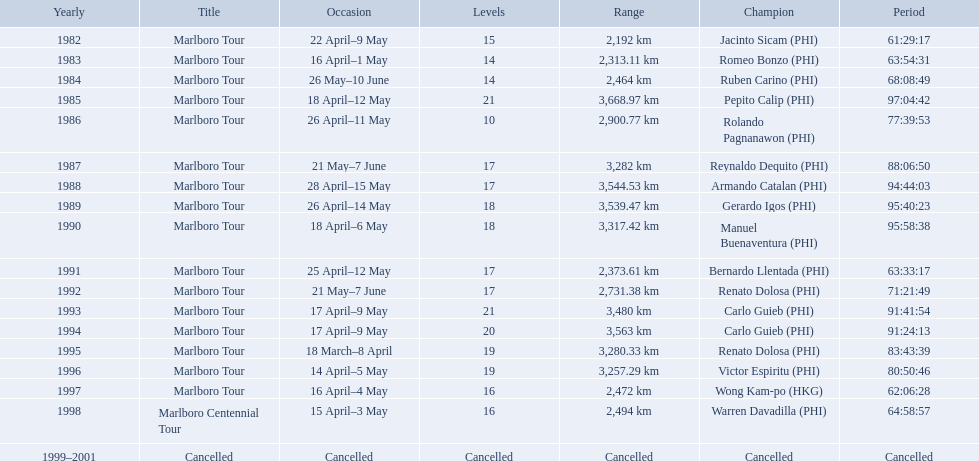What are the distances travelled on the tour? 2,192 km, 2,313.11 km, 2,464 km, 3,668.97 km, 2,900.77 km, 3,282 km, 3,544.53 km, 3,539.47 km, 3,317.42 km, 2,373.61 km, 2,731.38 km, 3,480 km, 3,563 km, 3,280.33 km, 3,257.29 km, 2,472 km, 2,494 km. Which of these are the largest? 3,668.97 km. What were the tour names during le tour de filipinas? Marlboro Tour, Marlboro Tour, Marlboro Tour, Marlboro Tour, Marlboro Tour, Marlboro Tour, Marlboro Tour, Marlboro Tour, Marlboro Tour, Marlboro Tour, Marlboro Tour, Marlboro Tour, Marlboro Tour, Marlboro Tour, Marlboro Tour, Marlboro Tour, Marlboro Centennial Tour, Cancelled. What were the recorded distances for each marlboro tour? 2,192 km, 2,313.11 km, 2,464 km, 3,668.97 km, 2,900.77 km, 3,282 km, 3,544.53 km, 3,539.47 km, 3,317.42 km, 2,373.61 km, 2,731.38 km, 3,480 km, 3,563 km, 3,280.33 km, 3,257.29 km, 2,472 km. And of those distances, which was the longest? 3,668.97 km. Who were all of the winners? Jacinto Sicam (PHI), Romeo Bonzo (PHI), Ruben Carino (PHI), Pepito Calip (PHI), Rolando Pagnanawon (PHI), Reynaldo Dequito (PHI), Armando Catalan (PHI), Gerardo Igos (PHI), Manuel Buenaventura (PHI), Bernardo Llentada (PHI), Renato Dolosa (PHI), Carlo Guieb (PHI), Carlo Guieb (PHI), Renato Dolosa (PHI), Victor Espiritu (PHI), Wong Kam-po (HKG), Warren Davadilla (PHI), Cancelled. When did they compete? 1982, 1983, 1984, 1985, 1986, 1987, 1988, 1989, 1990, 1991, 1992, 1993, 1994, 1995, 1996, 1997, 1998, 1999–2001. What were their finishing times? 61:29:17, 63:54:31, 68:08:49, 97:04:42, 77:39:53, 88:06:50, 94:44:03, 95:40:23, 95:58:38, 63:33:17, 71:21:49, 91:41:54, 91:24:13, 83:43:39, 80:50:46, 62:06:28, 64:58:57, Cancelled. And who won during 1998? Warren Davadilla (PHI). What was his time? 64:58:57. 